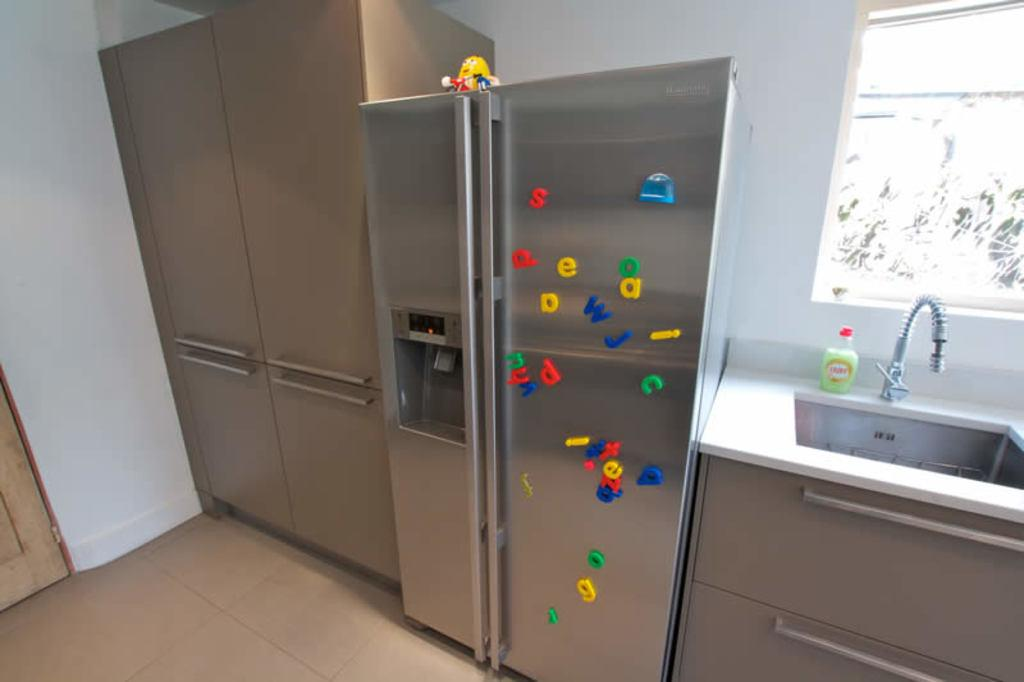<image>
Present a compact description of the photo's key features. A refrigerator with magnetic letters such as "s" and "e" 